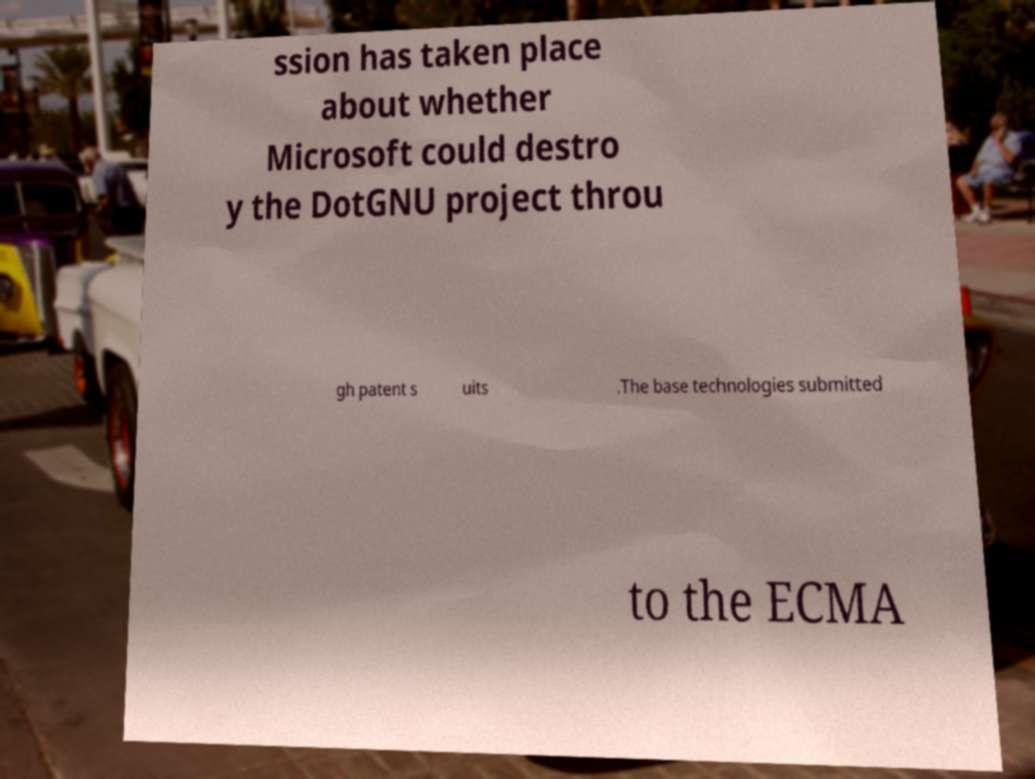Please read and relay the text visible in this image. What does it say? ssion has taken place about whether Microsoft could destro y the DotGNU project throu gh patent s uits .The base technologies submitted to the ECMA 